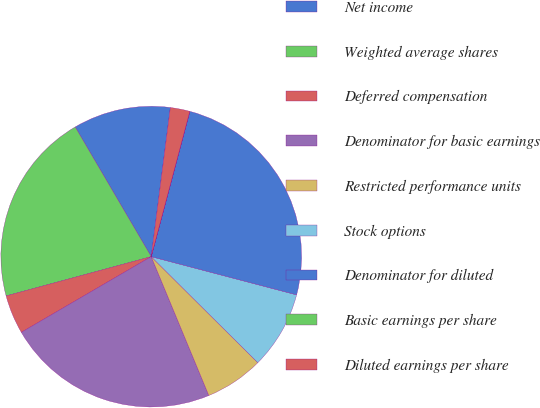Convert chart to OTSL. <chart><loc_0><loc_0><loc_500><loc_500><pie_chart><fcel>Net income<fcel>Weighted average shares<fcel>Deferred compensation<fcel>Denominator for basic earnings<fcel>Restricted performance units<fcel>Stock options<fcel>Denominator for diluted<fcel>Basic earnings per share<fcel>Diluted earnings per share<nl><fcel>10.47%<fcel>20.77%<fcel>4.19%<fcel>22.86%<fcel>6.28%<fcel>8.37%<fcel>24.95%<fcel>0.01%<fcel>2.1%<nl></chart> 